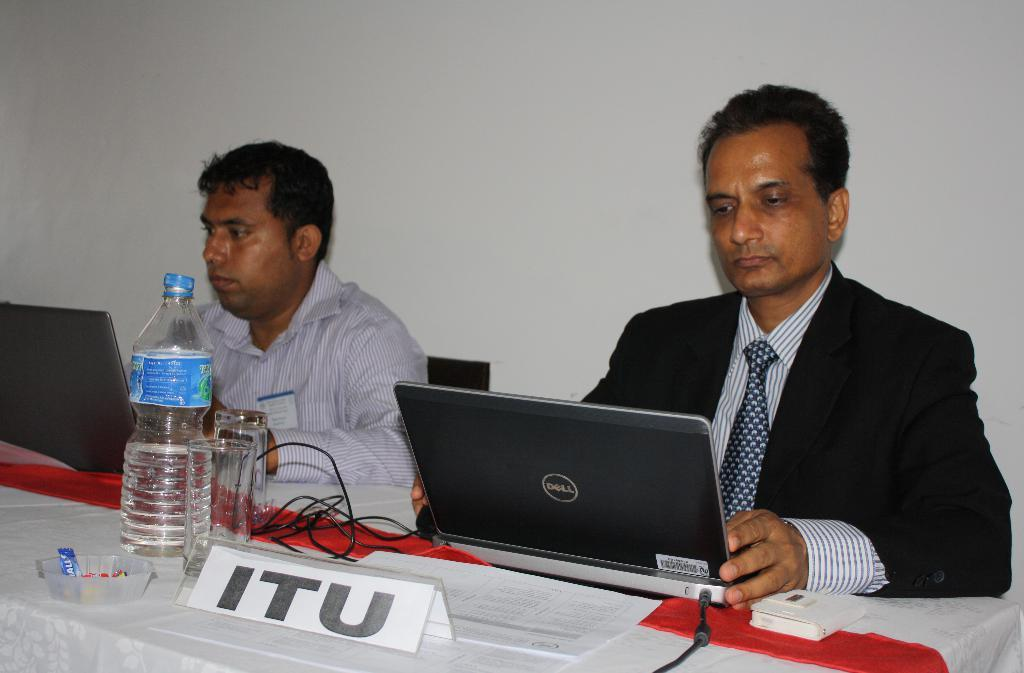<image>
Share a concise interpretation of the image provided. Two men looking at laptops behind a sign that says itu. 